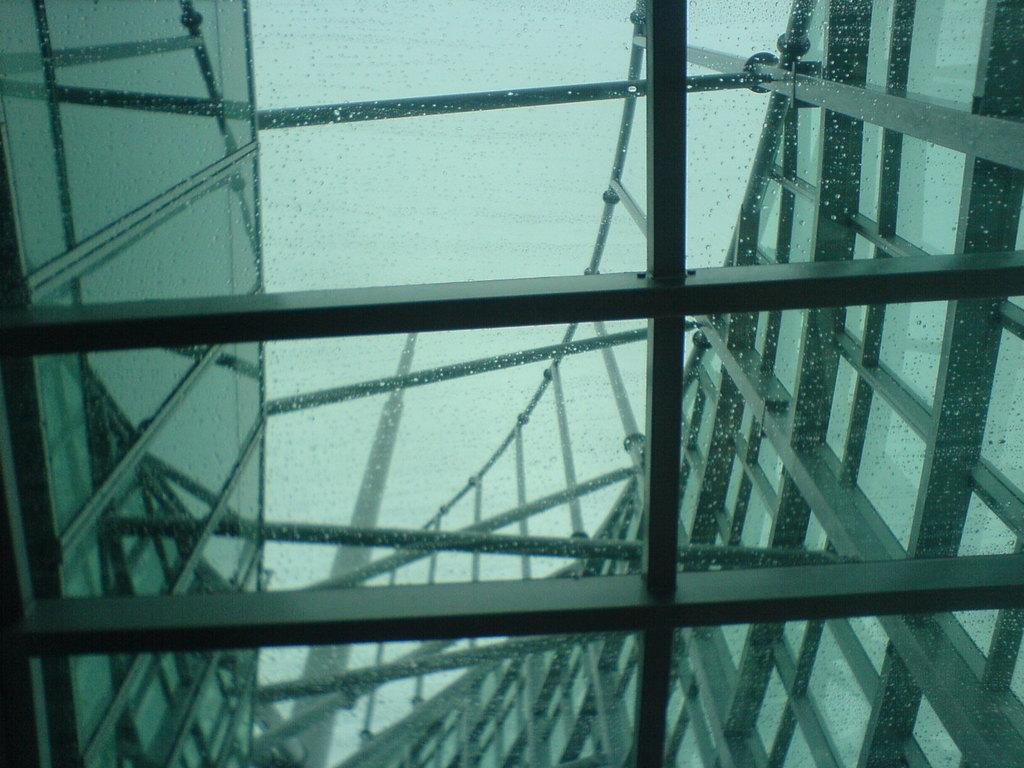What type of structure is present in the image? There is a building in the image. What is unique about the building's walls? The building has framed glass walls. What can be seen in the background of the image? The sky is visible in the background of the image. How many dimes can be seen on the roof of the building in the image? There are no dimes visible on the roof of the building in the image. What type of root is growing from the side of the building in the image? There are no roots growing from the side of the building in the image. 